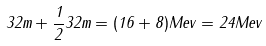Convert formula to latex. <formula><loc_0><loc_0><loc_500><loc_500>3 2 m + \frac { 1 } { 2 } 3 2 m = ( 1 6 + 8 ) M e v = 2 4 M e v</formula> 